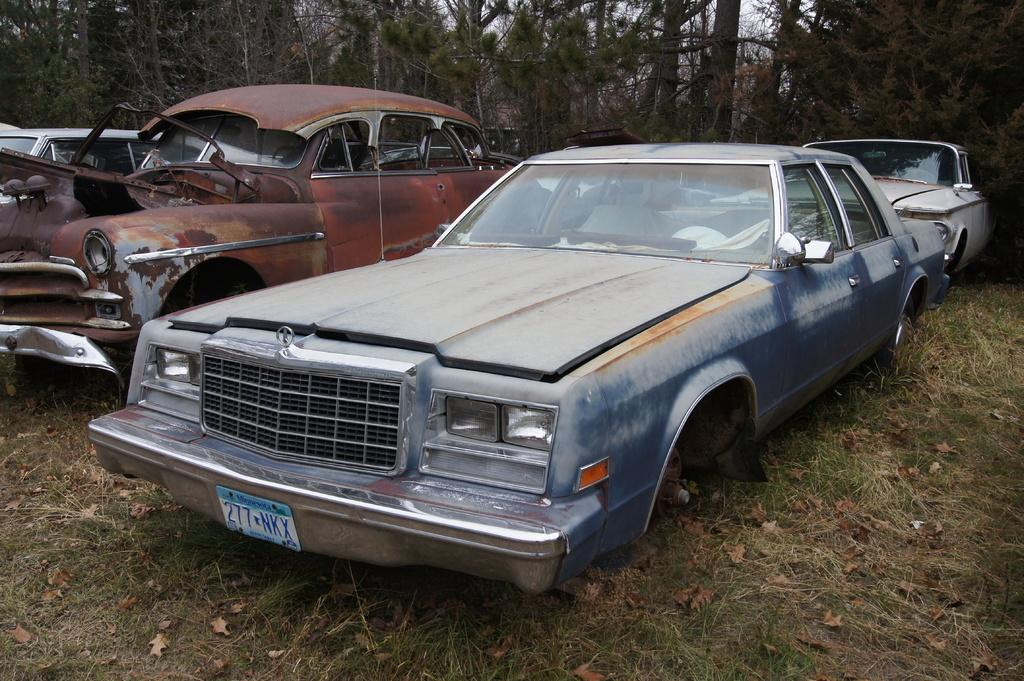What type of vehicles can be seen in the image? There are cars in the image. What type of vegetation is visible in the image? There is grass and trees visible in the image. What is present on the ground in the image? There are leaves on the ground in the image. What part of the natural environment is visible in the image? The sky is visible in the image. What type of spark can be seen coming from the dinner in the image? There is no dinner present in the image, and therefore no spark can be observed. 